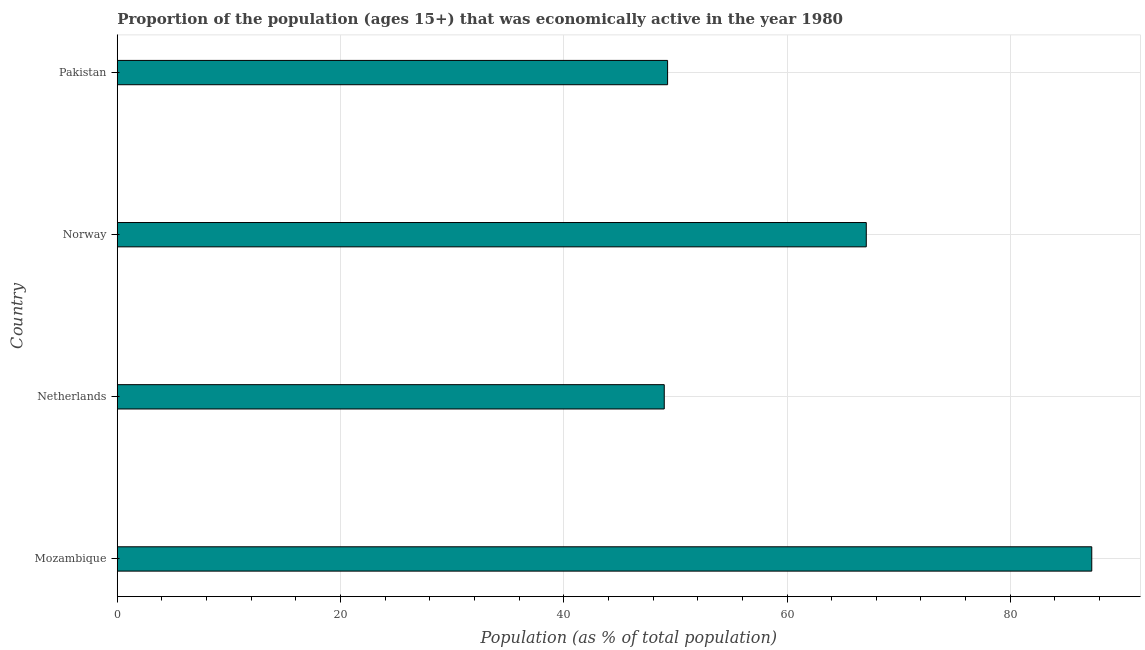Does the graph contain any zero values?
Keep it short and to the point. No. What is the title of the graph?
Provide a succinct answer. Proportion of the population (ages 15+) that was economically active in the year 1980. What is the label or title of the X-axis?
Your answer should be very brief. Population (as % of total population). What is the label or title of the Y-axis?
Your response must be concise. Country. What is the percentage of economically active population in Mozambique?
Make the answer very short. 87.3. Across all countries, what is the maximum percentage of economically active population?
Your answer should be compact. 87.3. In which country was the percentage of economically active population maximum?
Offer a very short reply. Mozambique. What is the sum of the percentage of economically active population?
Make the answer very short. 252.7. What is the difference between the percentage of economically active population in Mozambique and Netherlands?
Make the answer very short. 38.3. What is the average percentage of economically active population per country?
Provide a short and direct response. 63.17. What is the median percentage of economically active population?
Offer a very short reply. 58.2. What is the ratio of the percentage of economically active population in Norway to that in Pakistan?
Provide a succinct answer. 1.36. Is the percentage of economically active population in Mozambique less than that in Pakistan?
Your answer should be compact. No. What is the difference between the highest and the second highest percentage of economically active population?
Offer a terse response. 20.2. Is the sum of the percentage of economically active population in Mozambique and Pakistan greater than the maximum percentage of economically active population across all countries?
Your answer should be very brief. Yes. What is the difference between the highest and the lowest percentage of economically active population?
Provide a succinct answer. 38.3. In how many countries, is the percentage of economically active population greater than the average percentage of economically active population taken over all countries?
Provide a short and direct response. 2. Are the values on the major ticks of X-axis written in scientific E-notation?
Your response must be concise. No. What is the Population (as % of total population) in Mozambique?
Provide a succinct answer. 87.3. What is the Population (as % of total population) of Norway?
Offer a very short reply. 67.1. What is the Population (as % of total population) of Pakistan?
Provide a succinct answer. 49.3. What is the difference between the Population (as % of total population) in Mozambique and Netherlands?
Offer a terse response. 38.3. What is the difference between the Population (as % of total population) in Mozambique and Norway?
Offer a very short reply. 20.2. What is the difference between the Population (as % of total population) in Netherlands and Norway?
Provide a succinct answer. -18.1. What is the ratio of the Population (as % of total population) in Mozambique to that in Netherlands?
Your answer should be very brief. 1.78. What is the ratio of the Population (as % of total population) in Mozambique to that in Norway?
Your answer should be compact. 1.3. What is the ratio of the Population (as % of total population) in Mozambique to that in Pakistan?
Provide a short and direct response. 1.77. What is the ratio of the Population (as % of total population) in Netherlands to that in Norway?
Offer a terse response. 0.73. What is the ratio of the Population (as % of total population) in Norway to that in Pakistan?
Make the answer very short. 1.36. 